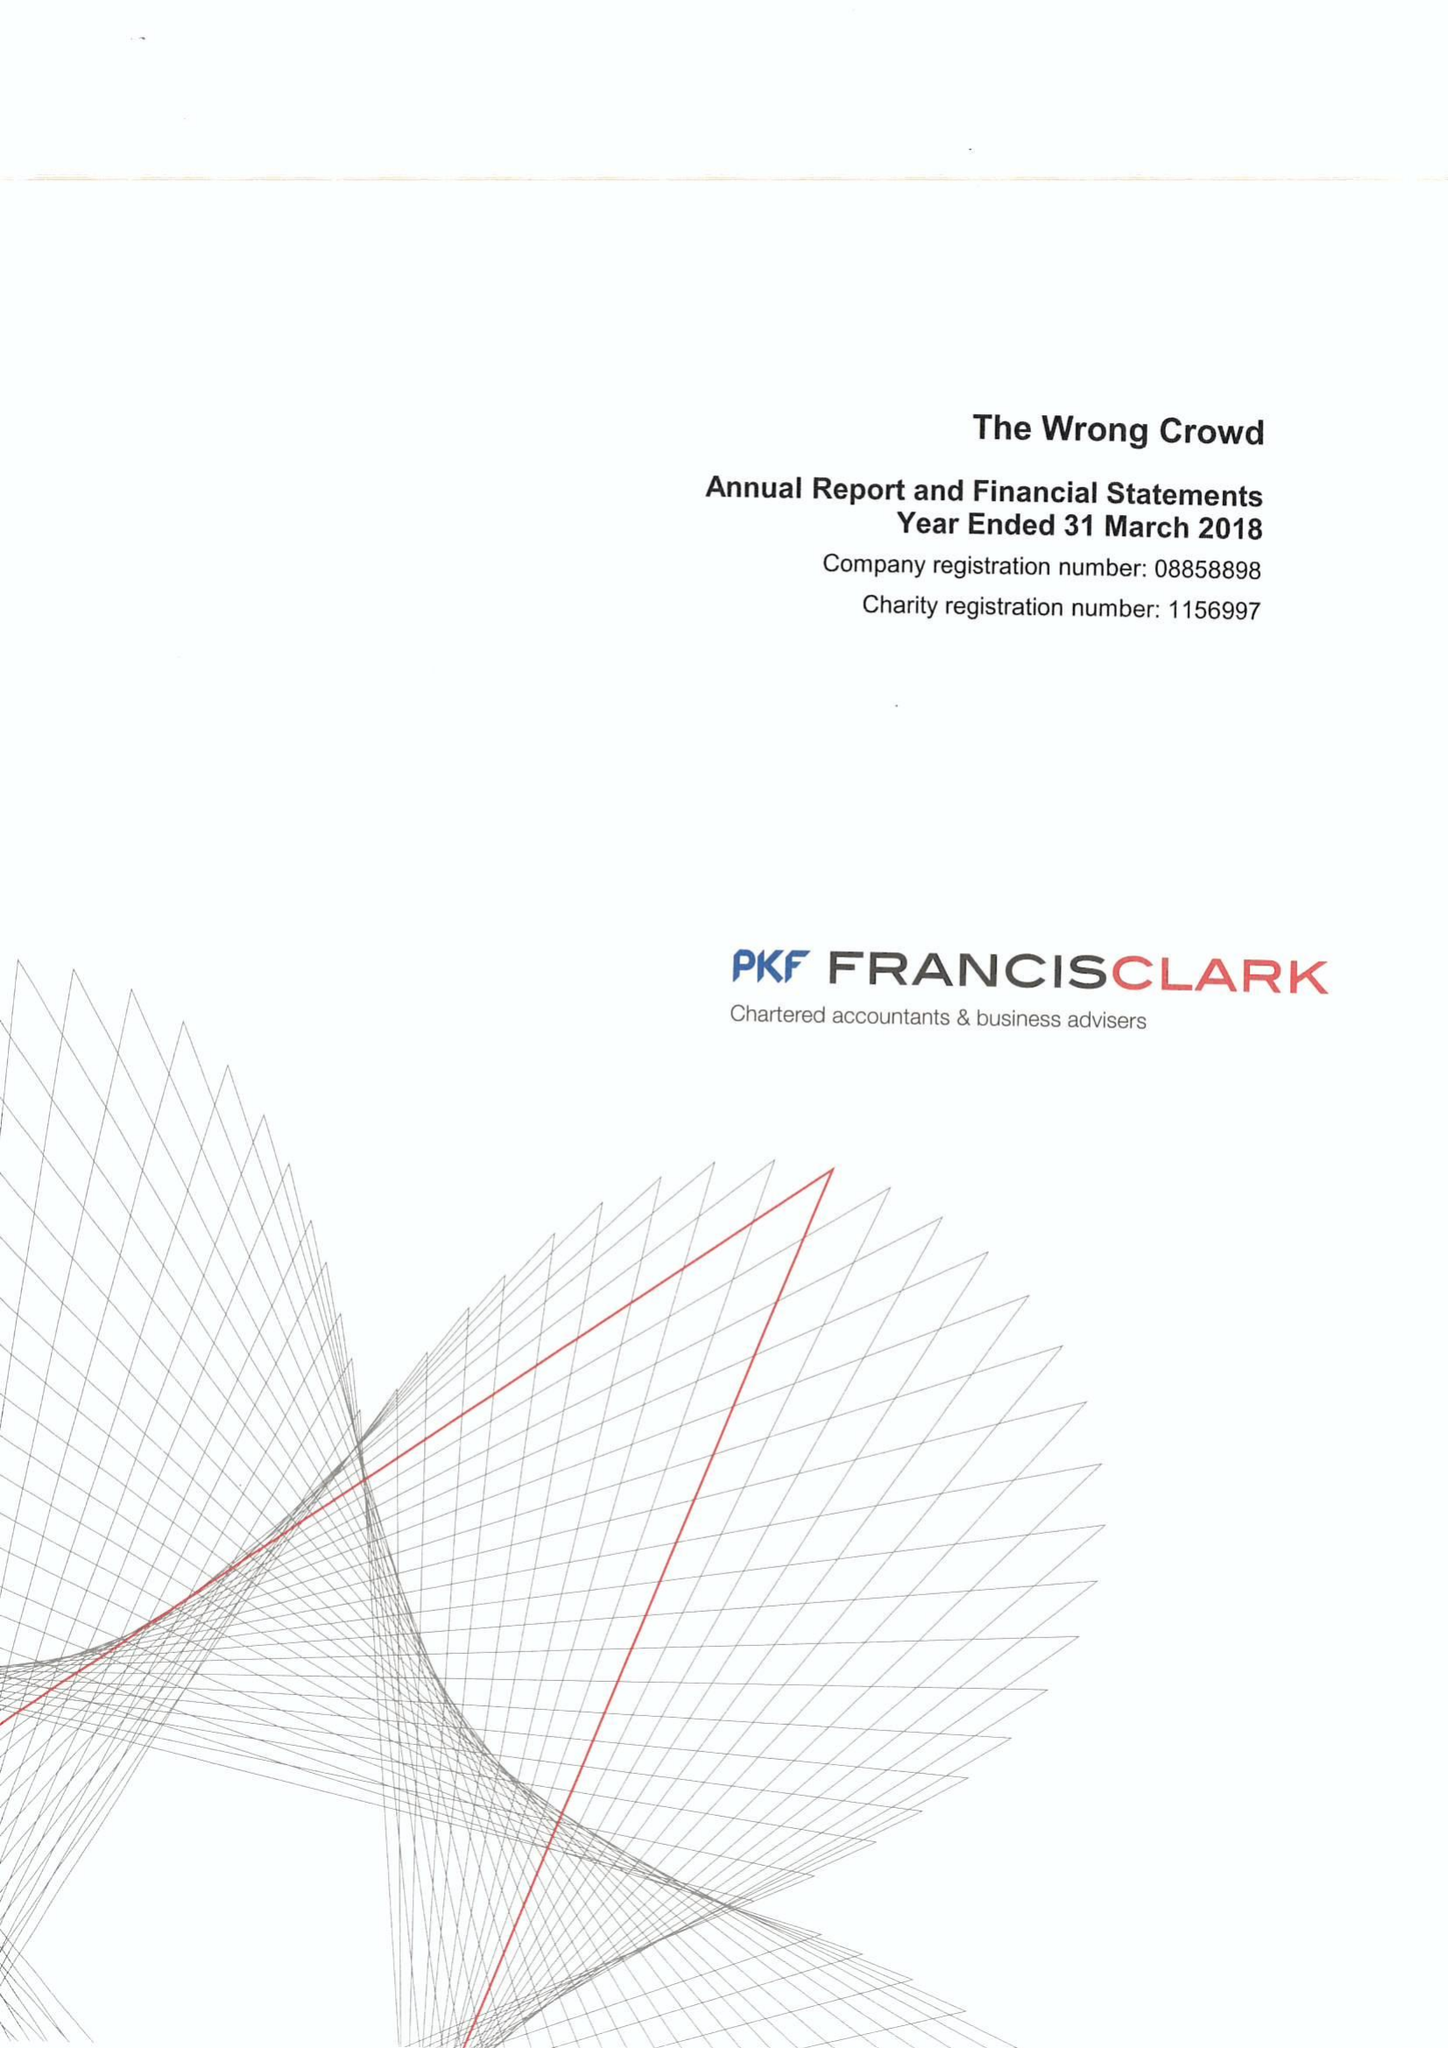What is the value for the address__street_line?
Answer the question using a single word or phrase. None 